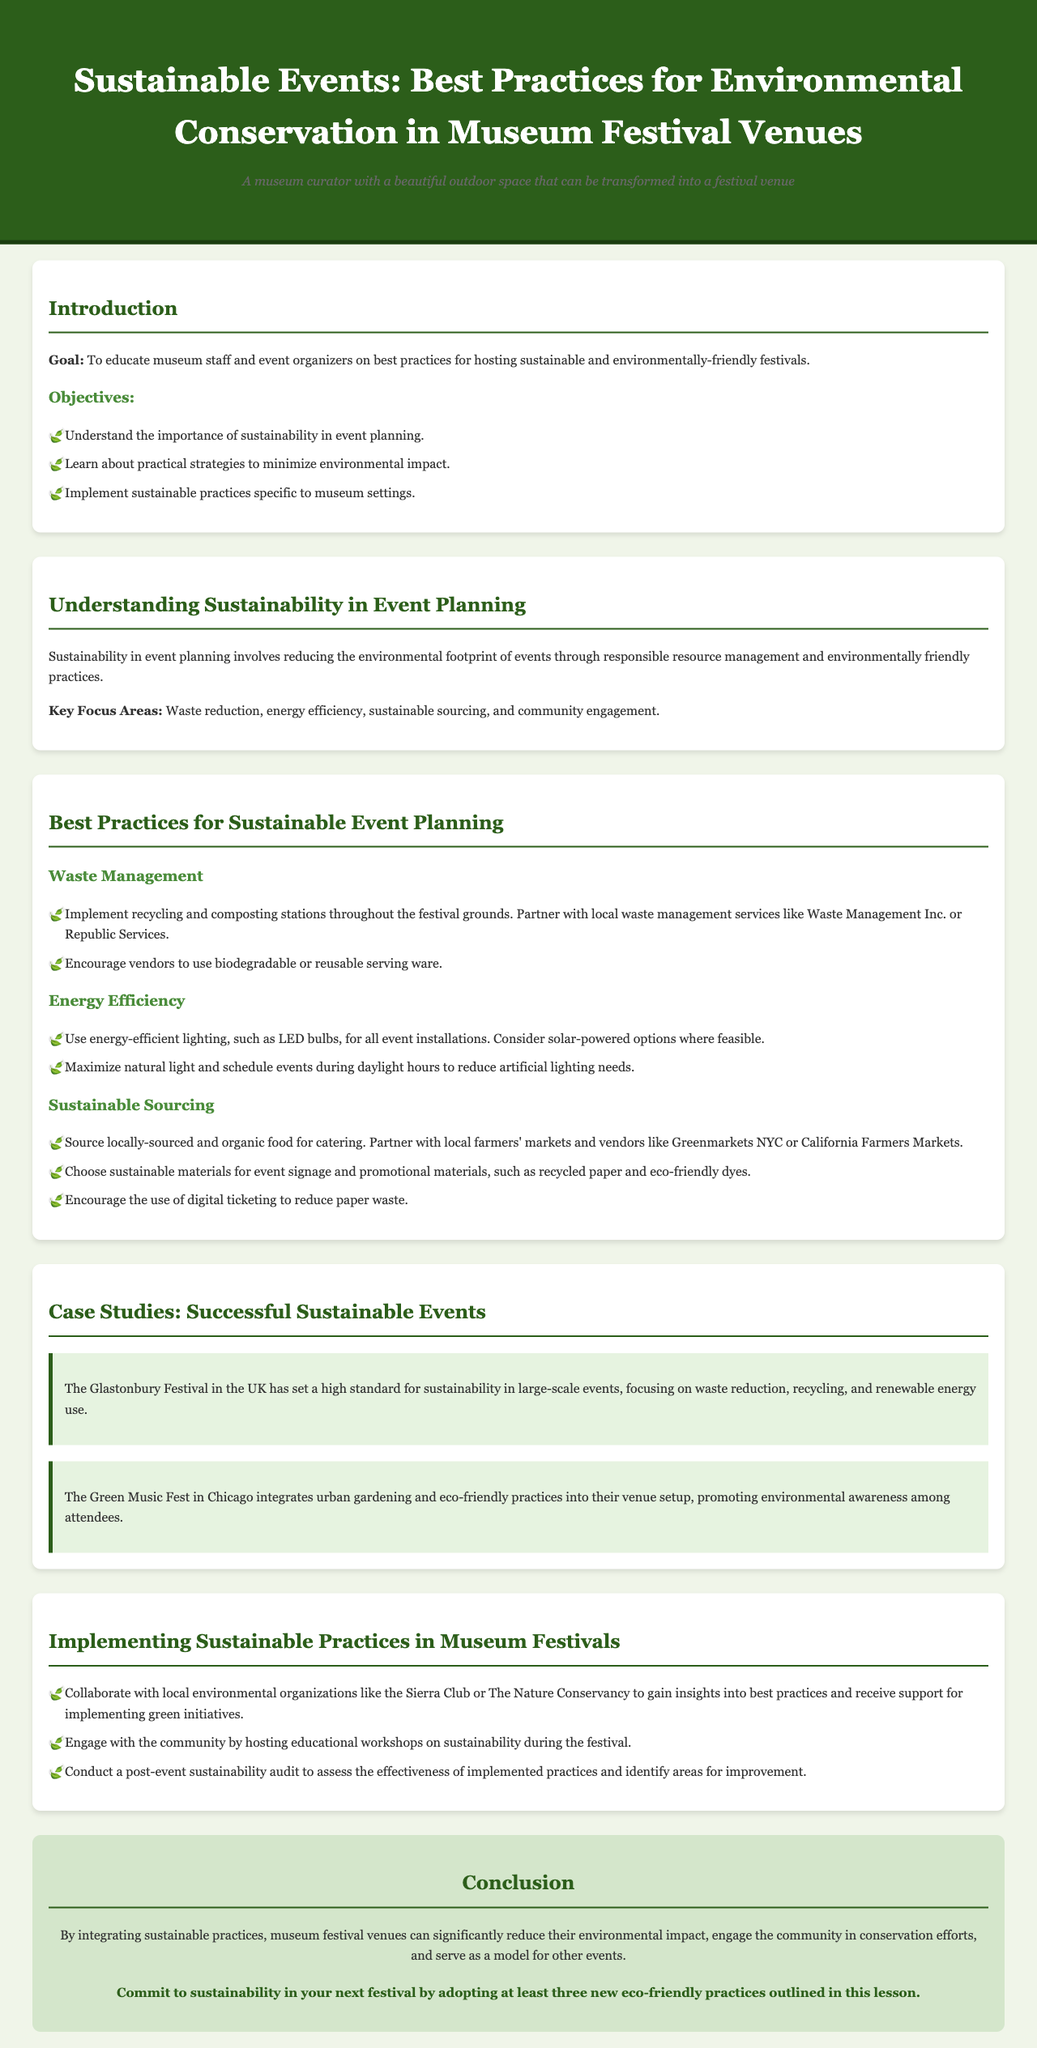What is the goal of this lesson plan? The goal is stated in the introduction section, highlighting the purpose of educating museum staff and event organizers.
Answer: To educate museum staff and event organizers on best practices for hosting sustainable and environmentally-friendly festivals What is one key focus area of sustainability in event planning? This information is provided under the key focus areas in the document.
Answer: Waste reduction What type of lighting is recommended for energy efficiency? The document suggests energy-efficient lighting options specifically for event installations under the energy efficiency section.
Answer: LED bulbs Name one organization to collaborate with for sustainable practices. The document lists local environmental organizations as potential collaborators under the implementation section.
Answer: Sierra Club How many successful sustainable events are featured as case studies? The document mentions two case studies related to successful sustainable events in the respective section.
Answer: Two What is a suggested action for post-event analysis? The document proposes conducting a sustainability audit after the event as part of the implementation practices.
Answer: Conduct a post-event sustainability audit What is encouraged to reduce paper waste during the event? This guideline for reducing paper waste is found under the sustainable sourcing section.
Answer: Digital ticketing What is one food sourcing recommendation? The sustainable sourcing section includes specific suggestions for food catering partnerships.
Answer: Locally-sourced and organic food 